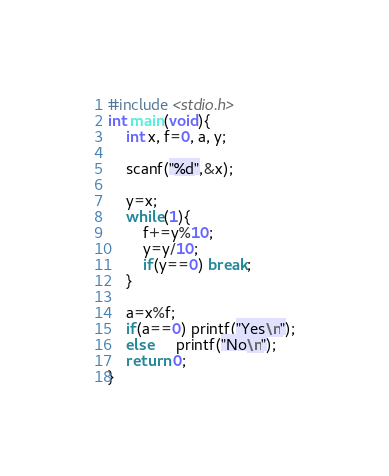<code> <loc_0><loc_0><loc_500><loc_500><_C_>#include <stdio.h>
int main(void){
    int x, f=0, a, y;
    
    scanf("%d",&x);
    
    y=x;
    while(1){
        f+=y%10;
        y=y/10;
        if(y==0) break;
    }
    
    a=x%f;
    if(a==0) printf("Yes\n");
    else     printf("No\n");
    return 0;
}</code> 